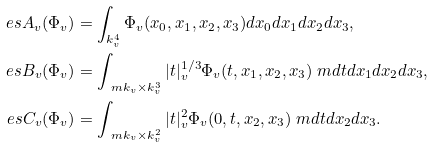Convert formula to latex. <formula><loc_0><loc_0><loc_500><loc_500>\ e s A _ { v } ( \Phi _ { v } ) & = \int _ { k _ { v } ^ { 4 } } \Phi _ { v } ( x _ { 0 } , x _ { 1 } , x _ { 2 } , x _ { 3 } ) d x _ { 0 } d x _ { 1 } d x _ { 2 } d x _ { 3 } , \\ \ e s B _ { v } ( \Phi _ { v } ) & = \int _ { \ m k _ { v } \times k _ { v } ^ { 3 } } | t | _ { v } ^ { 1 / 3 } \Phi _ { v } ( t , x _ { 1 } , x _ { 2 } , x _ { 3 } ) \ m d t d x _ { 1 } d x _ { 2 } d x _ { 3 } , \\ \ e s C _ { v } ( \Phi _ { v } ) & = \int _ { \ m k _ { v } \times k _ { v } ^ { 2 } } | t | _ { v } ^ { 2 } \Phi _ { v } ( 0 , t , x _ { 2 } , x _ { 3 } ) \ m d t d x _ { 2 } d x _ { 3 } .</formula> 